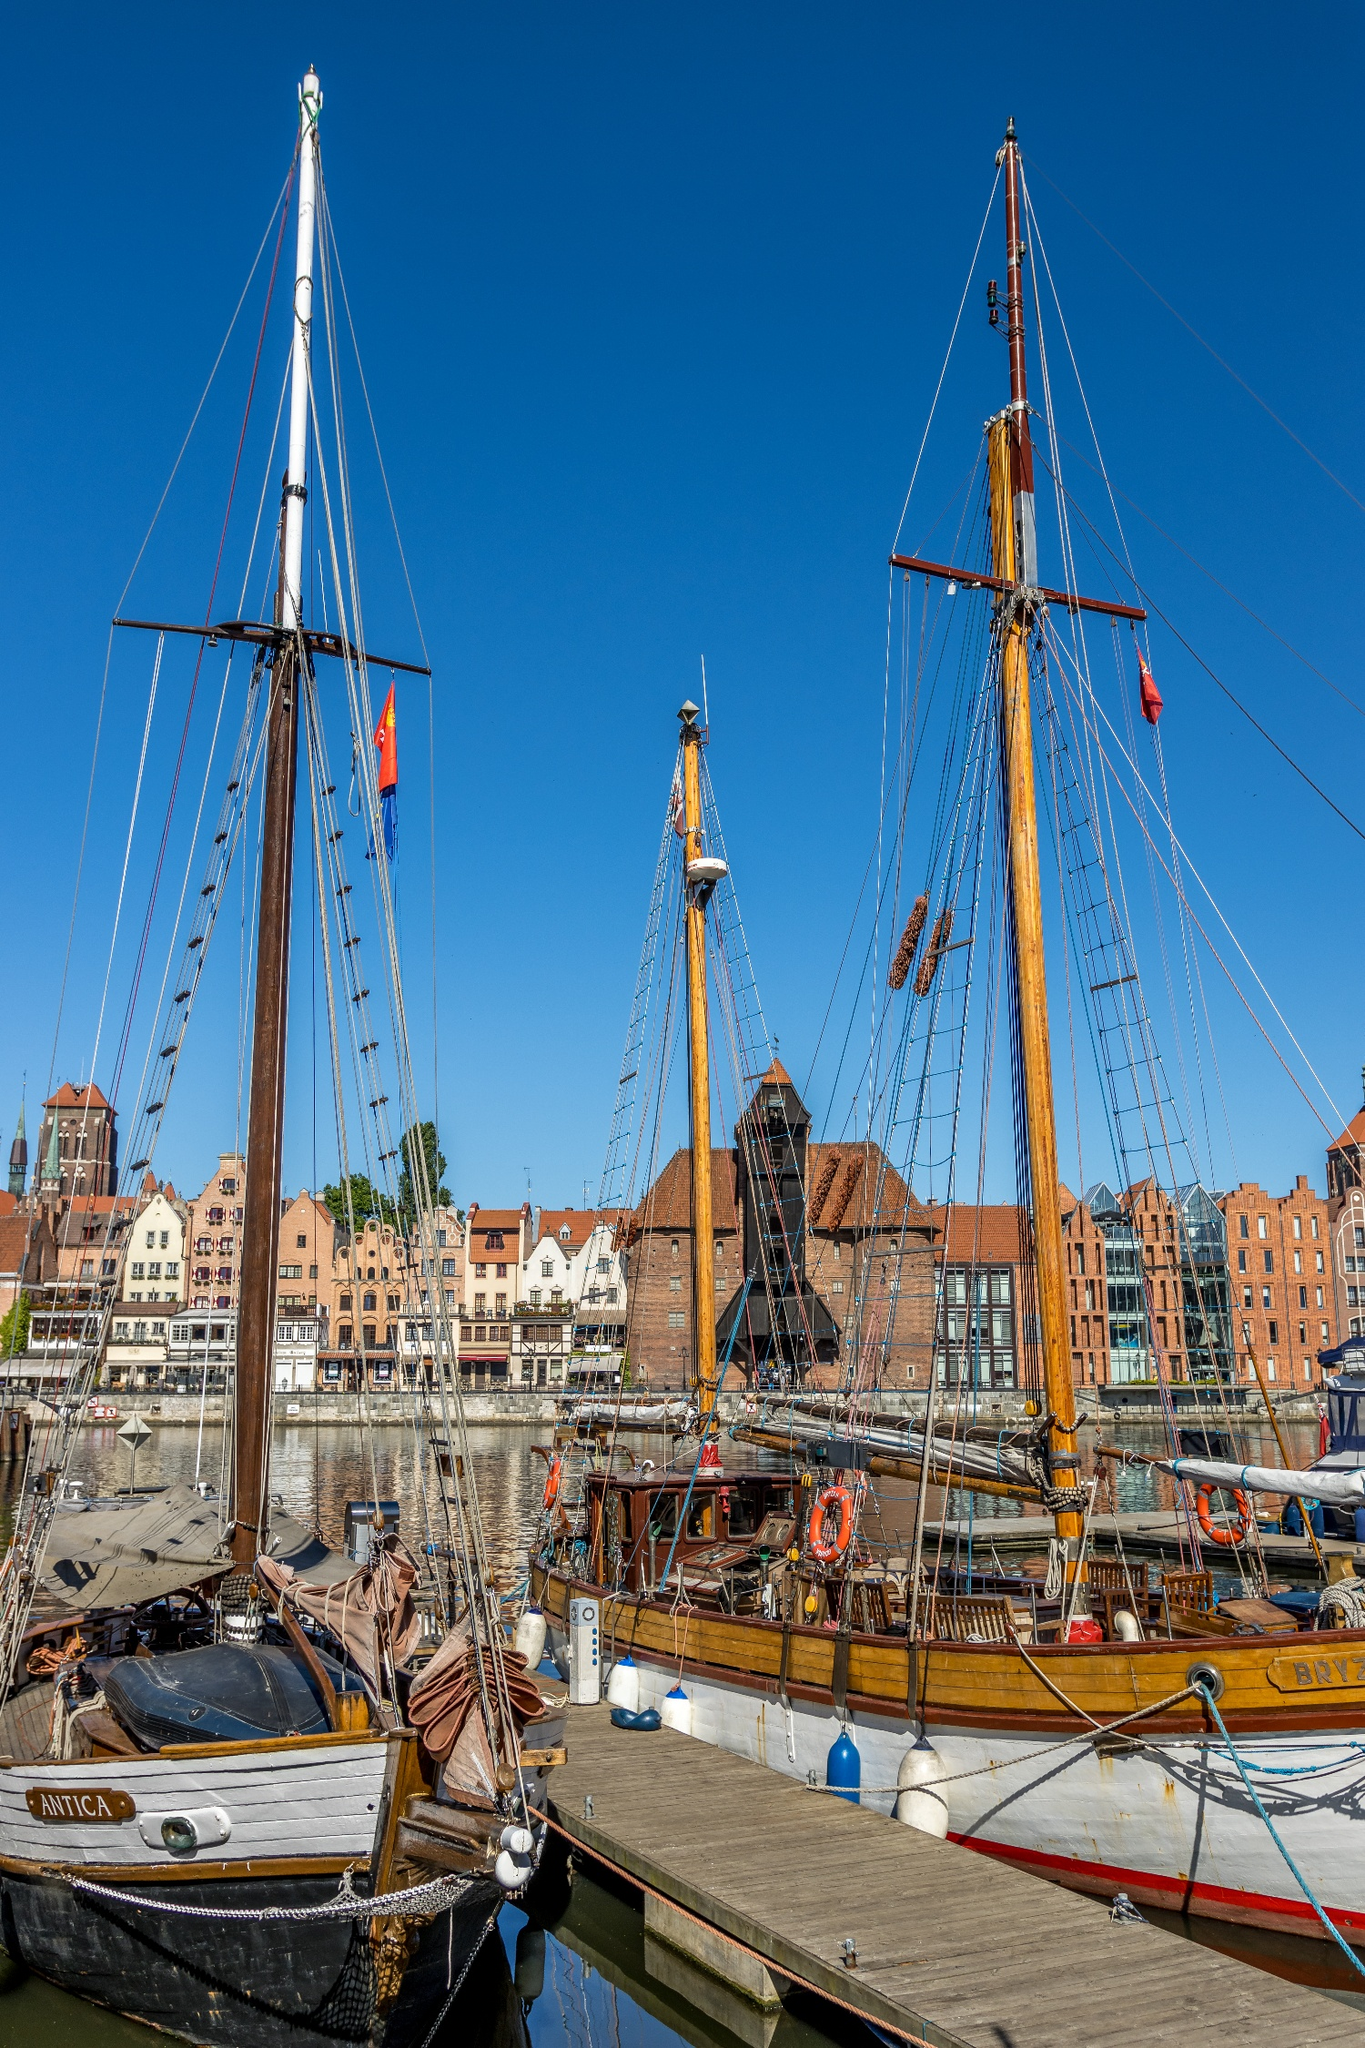Describe the architectural style seen in the buildings behind the ships. The buildings in the background exemplify traditional Northern European architecture, dating possibly from the medieval to early modern periods. They feature a mix of brickwork and what appears to be plaster, with some buildings showcasing exposed timber framing, a characteristic of the Hanseatic style prevalent in Baltic sea port cities. The roofs are steeply pitched and covered with red tiles, a common feature that helps with heavy rainfall drainage and adds to the aesthetic appeal. Additionally, the gables facing the harbor are ornately designed, adding character and historic depth to the waterfront. 